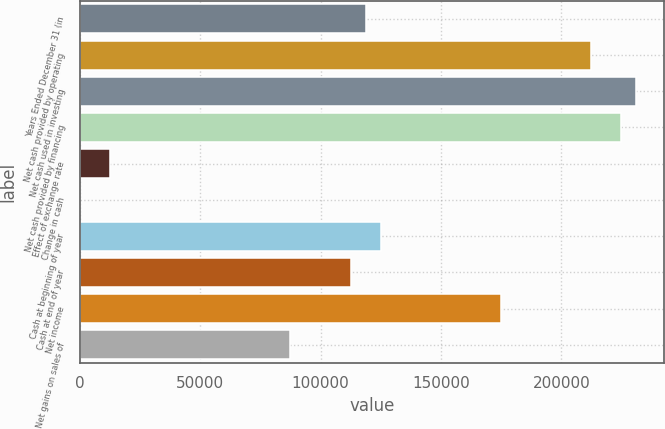Convert chart to OTSL. <chart><loc_0><loc_0><loc_500><loc_500><bar_chart><fcel>Years Ended December 31 (in<fcel>Net cash provided by operating<fcel>Net cash used in investing<fcel>Net cash provided by financing<fcel>Effect of exchange rate<fcel>Change in cash<fcel>Cash at beginning of year<fcel>Cash at end of year<fcel>Net income<fcel>Net gains on sales of<nl><fcel>118649<fcel>212231<fcel>230948<fcel>224709<fcel>12589.6<fcel>112<fcel>124888<fcel>112410<fcel>174798<fcel>87455.2<nl></chart> 